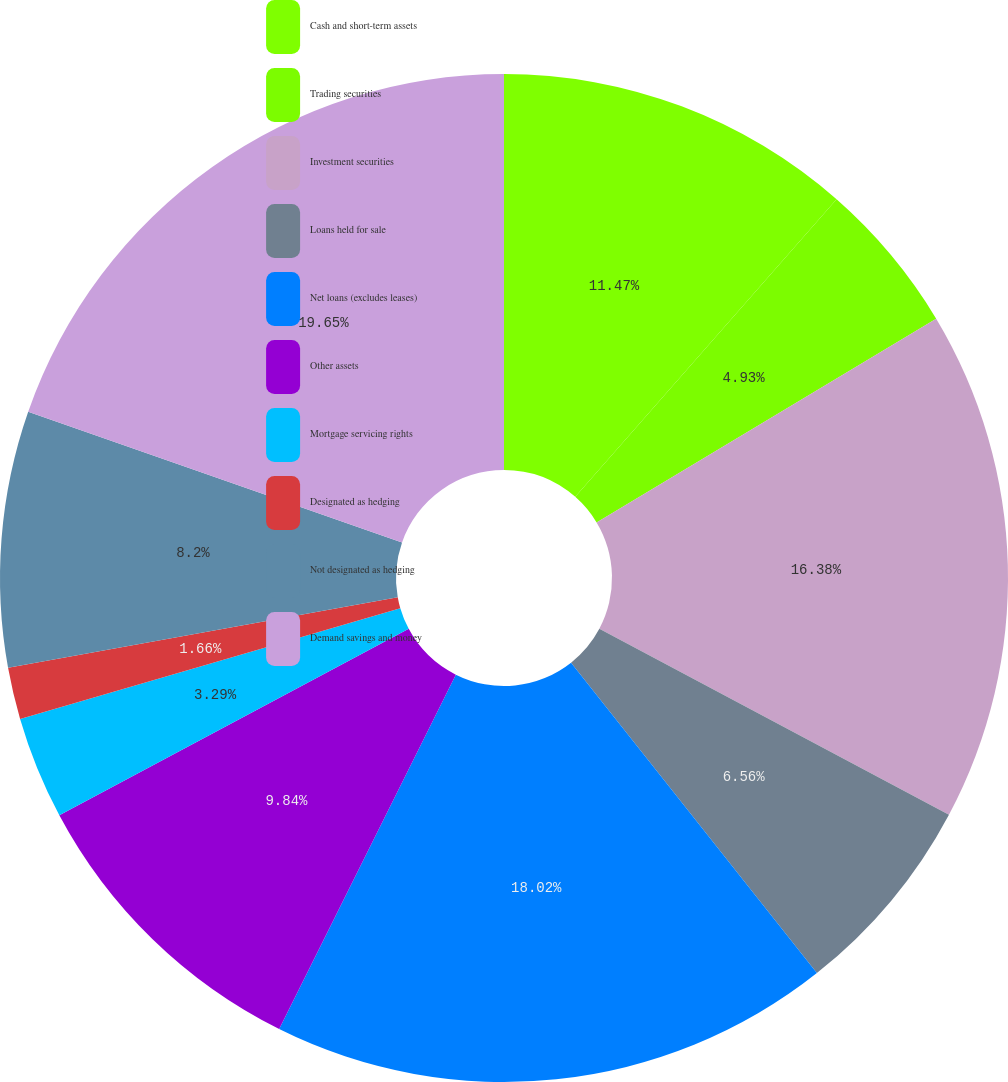Convert chart. <chart><loc_0><loc_0><loc_500><loc_500><pie_chart><fcel>Cash and short-term assets<fcel>Trading securities<fcel>Investment securities<fcel>Loans held for sale<fcel>Net loans (excludes leases)<fcel>Other assets<fcel>Mortgage servicing rights<fcel>Designated as hedging<fcel>Not designated as hedging<fcel>Demand savings and money<nl><fcel>11.47%<fcel>4.93%<fcel>16.38%<fcel>6.56%<fcel>18.02%<fcel>9.84%<fcel>3.29%<fcel>1.66%<fcel>8.2%<fcel>19.65%<nl></chart> 